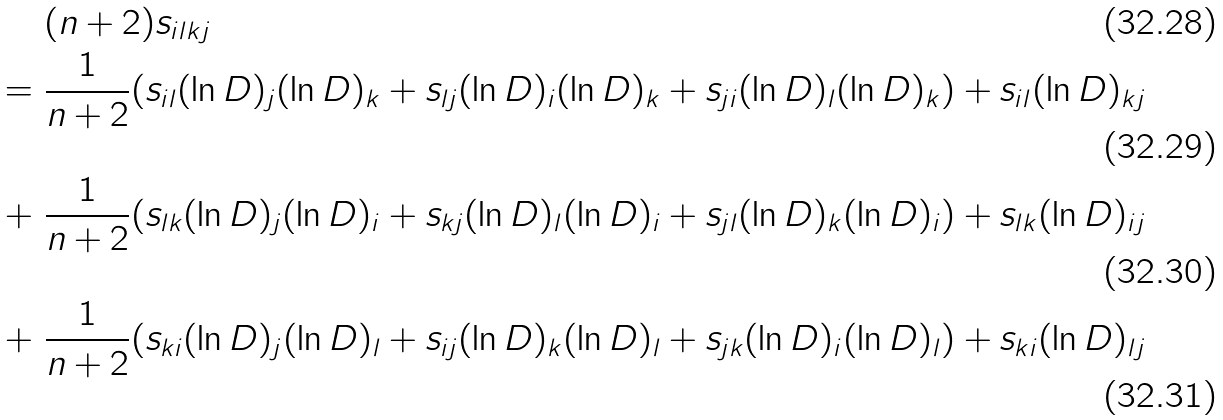Convert formula to latex. <formula><loc_0><loc_0><loc_500><loc_500>& ( n + 2 ) s _ { i l k j } \\ = \ & \frac { 1 } { n + 2 } ( s _ { i l } ( \ln D ) _ { j } ( \ln D ) _ { k } + s _ { l j } ( \ln D ) _ { i } ( \ln D ) _ { k } + s _ { j i } ( \ln D ) _ { l } ( \ln D ) _ { k } ) + s _ { i l } ( \ln D ) _ { k j } \\ + \ & \frac { 1 } { n + 2 } ( s _ { l k } ( \ln D ) _ { j } ( \ln D ) _ { i } + s _ { k j } ( \ln D ) _ { l } ( \ln D ) _ { i } + s _ { j l } ( \ln D ) _ { k } ( \ln D ) _ { i } ) + s _ { l k } ( \ln D ) _ { i j } \\ + \ & \frac { 1 } { n + 2 } ( s _ { k i } ( \ln D ) _ { j } ( \ln D ) _ { l } + s _ { i j } ( \ln D ) _ { k } ( \ln D ) _ { l } + s _ { j k } ( \ln D ) _ { i } ( \ln D ) _ { l } ) + s _ { k i } ( \ln D ) _ { l j }</formula> 